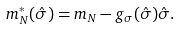Convert formula to latex. <formula><loc_0><loc_0><loc_500><loc_500>m _ { N } ^ { * } ( { \hat { \sigma } } ) = m _ { N } - g _ { \sigma } ( { \hat { \sigma } } ) { \hat { \sigma } } .</formula> 